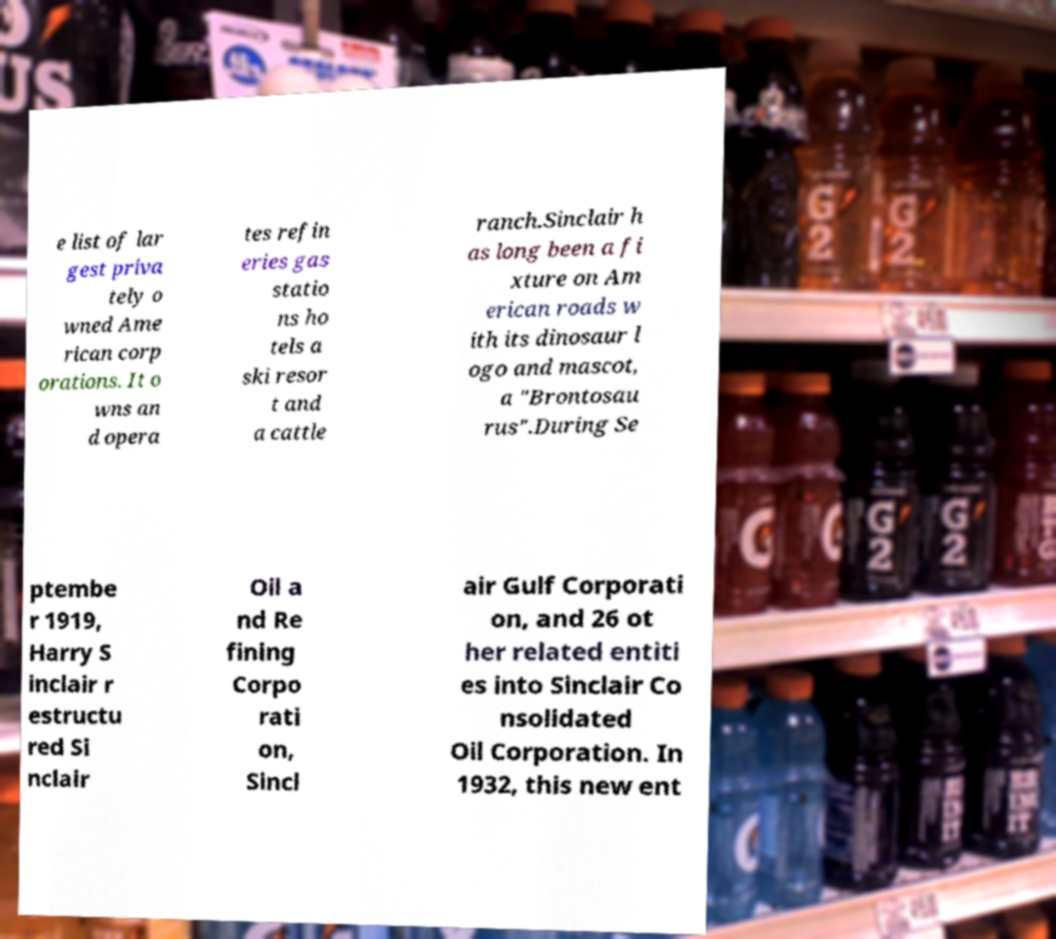Please identify and transcribe the text found in this image. e list of lar gest priva tely o wned Ame rican corp orations. It o wns an d opera tes refin eries gas statio ns ho tels a ski resor t and a cattle ranch.Sinclair h as long been a fi xture on Am erican roads w ith its dinosaur l ogo and mascot, a "Brontosau rus".During Se ptembe r 1919, Harry S inclair r estructu red Si nclair Oil a nd Re fining Corpo rati on, Sincl air Gulf Corporati on, and 26 ot her related entiti es into Sinclair Co nsolidated Oil Corporation. In 1932, this new ent 